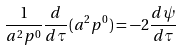Convert formula to latex. <formula><loc_0><loc_0><loc_500><loc_500>\frac { 1 } { a ^ { 2 } p ^ { 0 } } \frac { d } { d \tau } ( a ^ { 2 } p ^ { 0 } ) = - 2 \frac { d \psi } { d \tau }</formula> 